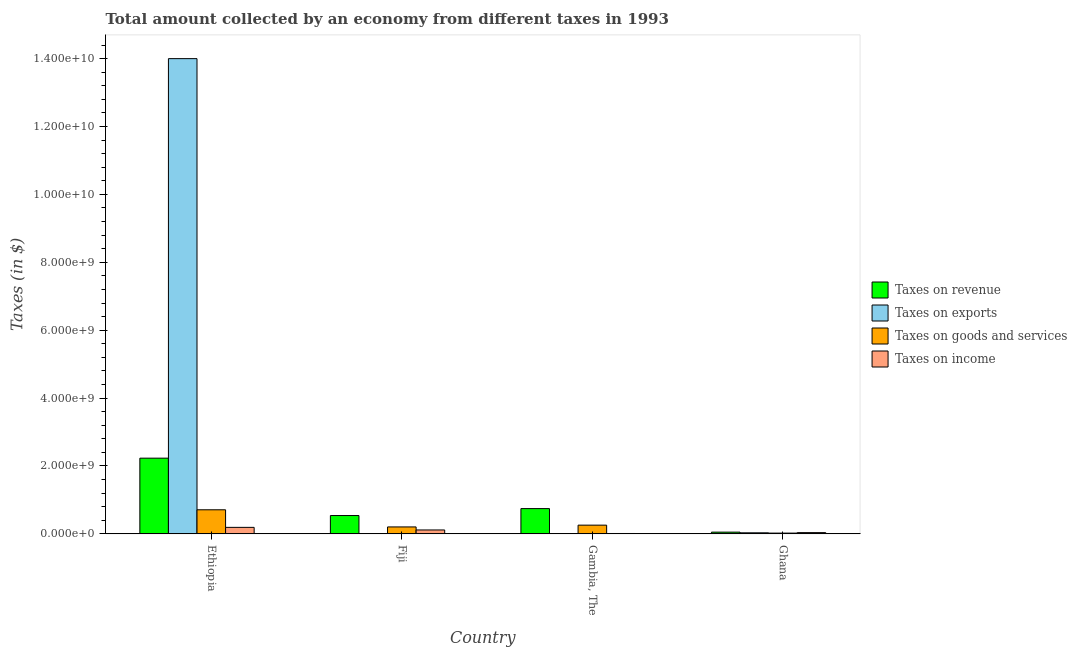What is the label of the 1st group of bars from the left?
Make the answer very short. Ethiopia. In how many cases, is the number of bars for a given country not equal to the number of legend labels?
Provide a short and direct response. 0. What is the amount collected as tax on goods in Ghana?
Give a very brief answer. 2.23e+07. Across all countries, what is the maximum amount collected as tax on income?
Give a very brief answer. 1.91e+08. Across all countries, what is the minimum amount collected as tax on exports?
Your response must be concise. 3.65e+05. In which country was the amount collected as tax on exports maximum?
Make the answer very short. Ethiopia. In which country was the amount collected as tax on revenue minimum?
Your answer should be compact. Ghana. What is the total amount collected as tax on income in the graph?
Offer a very short reply. 3.53e+08. What is the difference between the amount collected as tax on goods in Fiji and that in Ghana?
Your response must be concise. 1.82e+08. What is the difference between the amount collected as tax on income in Ghana and the amount collected as tax on revenue in Gambia, The?
Your response must be concise. -7.08e+08. What is the average amount collected as tax on goods per country?
Make the answer very short. 2.98e+08. What is the difference between the amount collected as tax on income and amount collected as tax on revenue in Ethiopia?
Ensure brevity in your answer.  -2.04e+09. What is the ratio of the amount collected as tax on goods in Gambia, The to that in Ghana?
Keep it short and to the point. 11.51. Is the amount collected as tax on revenue in Ethiopia less than that in Fiji?
Offer a terse response. No. What is the difference between the highest and the second highest amount collected as tax on exports?
Provide a short and direct response. 1.40e+1. What is the difference between the highest and the lowest amount collected as tax on income?
Give a very brief answer. 1.80e+08. Is it the case that in every country, the sum of the amount collected as tax on goods and amount collected as tax on revenue is greater than the sum of amount collected as tax on income and amount collected as tax on exports?
Offer a terse response. No. What does the 2nd bar from the left in Ghana represents?
Ensure brevity in your answer.  Taxes on exports. What does the 3rd bar from the right in Ethiopia represents?
Offer a terse response. Taxes on exports. Is it the case that in every country, the sum of the amount collected as tax on revenue and amount collected as tax on exports is greater than the amount collected as tax on goods?
Your answer should be very brief. Yes. How many bars are there?
Keep it short and to the point. 16. Are all the bars in the graph horizontal?
Give a very brief answer. No. How many countries are there in the graph?
Your response must be concise. 4. Does the graph contain any zero values?
Offer a very short reply. No. How are the legend labels stacked?
Make the answer very short. Vertical. What is the title of the graph?
Make the answer very short. Total amount collected by an economy from different taxes in 1993. What is the label or title of the X-axis?
Provide a short and direct response. Country. What is the label or title of the Y-axis?
Provide a short and direct response. Taxes (in $). What is the Taxes (in $) of Taxes on revenue in Ethiopia?
Your response must be concise. 2.23e+09. What is the Taxes (in $) of Taxes on exports in Ethiopia?
Your answer should be compact. 1.40e+1. What is the Taxes (in $) in Taxes on goods and services in Ethiopia?
Offer a very short reply. 7.09e+08. What is the Taxes (in $) of Taxes on income in Ethiopia?
Offer a very short reply. 1.91e+08. What is the Taxes (in $) in Taxes on revenue in Fiji?
Your response must be concise. 5.40e+08. What is the Taxes (in $) in Taxes on exports in Fiji?
Give a very brief answer. 1.00e+06. What is the Taxes (in $) of Taxes on goods and services in Fiji?
Your answer should be very brief. 2.04e+08. What is the Taxes (in $) of Taxes on income in Fiji?
Ensure brevity in your answer.  1.15e+08. What is the Taxes (in $) in Taxes on revenue in Gambia, The?
Your answer should be compact. 7.44e+08. What is the Taxes (in $) of Taxes on exports in Gambia, The?
Offer a very short reply. 3.65e+05. What is the Taxes (in $) in Taxes on goods and services in Gambia, The?
Offer a very short reply. 2.57e+08. What is the Taxes (in $) of Taxes on income in Gambia, The?
Provide a succinct answer. 1.10e+07. What is the Taxes (in $) in Taxes on revenue in Ghana?
Your answer should be compact. 5.09e+07. What is the Taxes (in $) in Taxes on exports in Ghana?
Ensure brevity in your answer.  3.10e+07. What is the Taxes (in $) in Taxes on goods and services in Ghana?
Provide a short and direct response. 2.23e+07. What is the Taxes (in $) of Taxes on income in Ghana?
Provide a short and direct response. 3.64e+07. Across all countries, what is the maximum Taxes (in $) in Taxes on revenue?
Provide a short and direct response. 2.23e+09. Across all countries, what is the maximum Taxes (in $) of Taxes on exports?
Give a very brief answer. 1.40e+1. Across all countries, what is the maximum Taxes (in $) of Taxes on goods and services?
Ensure brevity in your answer.  7.09e+08. Across all countries, what is the maximum Taxes (in $) in Taxes on income?
Your answer should be compact. 1.91e+08. Across all countries, what is the minimum Taxes (in $) in Taxes on revenue?
Provide a short and direct response. 5.09e+07. Across all countries, what is the minimum Taxes (in $) in Taxes on exports?
Make the answer very short. 3.65e+05. Across all countries, what is the minimum Taxes (in $) of Taxes on goods and services?
Provide a succinct answer. 2.23e+07. Across all countries, what is the minimum Taxes (in $) of Taxes on income?
Offer a terse response. 1.10e+07. What is the total Taxes (in $) in Taxes on revenue in the graph?
Your answer should be compact. 3.57e+09. What is the total Taxes (in $) of Taxes on exports in the graph?
Provide a succinct answer. 1.40e+1. What is the total Taxes (in $) of Taxes on goods and services in the graph?
Offer a terse response. 1.19e+09. What is the total Taxes (in $) of Taxes on income in the graph?
Give a very brief answer. 3.53e+08. What is the difference between the Taxes (in $) of Taxes on revenue in Ethiopia and that in Fiji?
Give a very brief answer. 1.69e+09. What is the difference between the Taxes (in $) in Taxes on exports in Ethiopia and that in Fiji?
Offer a terse response. 1.40e+1. What is the difference between the Taxes (in $) in Taxes on goods and services in Ethiopia and that in Fiji?
Your answer should be very brief. 5.05e+08. What is the difference between the Taxes (in $) of Taxes on income in Ethiopia and that in Fiji?
Keep it short and to the point. 7.64e+07. What is the difference between the Taxes (in $) of Taxes on revenue in Ethiopia and that in Gambia, The?
Your answer should be very brief. 1.49e+09. What is the difference between the Taxes (in $) of Taxes on exports in Ethiopia and that in Gambia, The?
Offer a terse response. 1.40e+1. What is the difference between the Taxes (in $) of Taxes on goods and services in Ethiopia and that in Gambia, The?
Your response must be concise. 4.53e+08. What is the difference between the Taxes (in $) of Taxes on income in Ethiopia and that in Gambia, The?
Give a very brief answer. 1.80e+08. What is the difference between the Taxes (in $) in Taxes on revenue in Ethiopia and that in Ghana?
Your answer should be compact. 2.18e+09. What is the difference between the Taxes (in $) of Taxes on exports in Ethiopia and that in Ghana?
Your answer should be compact. 1.40e+1. What is the difference between the Taxes (in $) in Taxes on goods and services in Ethiopia and that in Ghana?
Offer a terse response. 6.87e+08. What is the difference between the Taxes (in $) of Taxes on income in Ethiopia and that in Ghana?
Keep it short and to the point. 1.55e+08. What is the difference between the Taxes (in $) of Taxes on revenue in Fiji and that in Gambia, The?
Your answer should be very brief. -2.04e+08. What is the difference between the Taxes (in $) of Taxes on exports in Fiji and that in Gambia, The?
Your response must be concise. 6.35e+05. What is the difference between the Taxes (in $) of Taxes on goods and services in Fiji and that in Gambia, The?
Offer a very short reply. -5.24e+07. What is the difference between the Taxes (in $) in Taxes on income in Fiji and that in Gambia, The?
Keep it short and to the point. 1.04e+08. What is the difference between the Taxes (in $) of Taxes on revenue in Fiji and that in Ghana?
Make the answer very short. 4.89e+08. What is the difference between the Taxes (in $) in Taxes on exports in Fiji and that in Ghana?
Keep it short and to the point. -3.00e+07. What is the difference between the Taxes (in $) in Taxes on goods and services in Fiji and that in Ghana?
Offer a terse response. 1.82e+08. What is the difference between the Taxes (in $) of Taxes on income in Fiji and that in Ghana?
Your answer should be very brief. 7.83e+07. What is the difference between the Taxes (in $) in Taxes on revenue in Gambia, The and that in Ghana?
Make the answer very short. 6.93e+08. What is the difference between the Taxes (in $) in Taxes on exports in Gambia, The and that in Ghana?
Keep it short and to the point. -3.06e+07. What is the difference between the Taxes (in $) of Taxes on goods and services in Gambia, The and that in Ghana?
Provide a short and direct response. 2.34e+08. What is the difference between the Taxes (in $) of Taxes on income in Gambia, The and that in Ghana?
Provide a succinct answer. -2.54e+07. What is the difference between the Taxes (in $) of Taxes on revenue in Ethiopia and the Taxes (in $) of Taxes on exports in Fiji?
Offer a terse response. 2.23e+09. What is the difference between the Taxes (in $) in Taxes on revenue in Ethiopia and the Taxes (in $) in Taxes on goods and services in Fiji?
Your answer should be compact. 2.03e+09. What is the difference between the Taxes (in $) in Taxes on revenue in Ethiopia and the Taxes (in $) in Taxes on income in Fiji?
Offer a terse response. 2.12e+09. What is the difference between the Taxes (in $) of Taxes on exports in Ethiopia and the Taxes (in $) of Taxes on goods and services in Fiji?
Keep it short and to the point. 1.38e+1. What is the difference between the Taxes (in $) in Taxes on exports in Ethiopia and the Taxes (in $) in Taxes on income in Fiji?
Give a very brief answer. 1.39e+1. What is the difference between the Taxes (in $) of Taxes on goods and services in Ethiopia and the Taxes (in $) of Taxes on income in Fiji?
Provide a succinct answer. 5.94e+08. What is the difference between the Taxes (in $) of Taxes on revenue in Ethiopia and the Taxes (in $) of Taxes on exports in Gambia, The?
Your answer should be compact. 2.23e+09. What is the difference between the Taxes (in $) of Taxes on revenue in Ethiopia and the Taxes (in $) of Taxes on goods and services in Gambia, The?
Give a very brief answer. 1.97e+09. What is the difference between the Taxes (in $) of Taxes on revenue in Ethiopia and the Taxes (in $) of Taxes on income in Gambia, The?
Offer a very short reply. 2.22e+09. What is the difference between the Taxes (in $) of Taxes on exports in Ethiopia and the Taxes (in $) of Taxes on goods and services in Gambia, The?
Ensure brevity in your answer.  1.37e+1. What is the difference between the Taxes (in $) in Taxes on exports in Ethiopia and the Taxes (in $) in Taxes on income in Gambia, The?
Offer a very short reply. 1.40e+1. What is the difference between the Taxes (in $) of Taxes on goods and services in Ethiopia and the Taxes (in $) of Taxes on income in Gambia, The?
Your answer should be very brief. 6.98e+08. What is the difference between the Taxes (in $) of Taxes on revenue in Ethiopia and the Taxes (in $) of Taxes on exports in Ghana?
Provide a succinct answer. 2.20e+09. What is the difference between the Taxes (in $) in Taxes on revenue in Ethiopia and the Taxes (in $) in Taxes on goods and services in Ghana?
Offer a very short reply. 2.21e+09. What is the difference between the Taxes (in $) of Taxes on revenue in Ethiopia and the Taxes (in $) of Taxes on income in Ghana?
Make the answer very short. 2.19e+09. What is the difference between the Taxes (in $) of Taxes on exports in Ethiopia and the Taxes (in $) of Taxes on goods and services in Ghana?
Keep it short and to the point. 1.40e+1. What is the difference between the Taxes (in $) in Taxes on exports in Ethiopia and the Taxes (in $) in Taxes on income in Ghana?
Make the answer very short. 1.40e+1. What is the difference between the Taxes (in $) in Taxes on goods and services in Ethiopia and the Taxes (in $) in Taxes on income in Ghana?
Your answer should be very brief. 6.73e+08. What is the difference between the Taxes (in $) of Taxes on revenue in Fiji and the Taxes (in $) of Taxes on exports in Gambia, The?
Keep it short and to the point. 5.40e+08. What is the difference between the Taxes (in $) in Taxes on revenue in Fiji and the Taxes (in $) in Taxes on goods and services in Gambia, The?
Your answer should be compact. 2.83e+08. What is the difference between the Taxes (in $) in Taxes on revenue in Fiji and the Taxes (in $) in Taxes on income in Gambia, The?
Offer a very short reply. 5.29e+08. What is the difference between the Taxes (in $) of Taxes on exports in Fiji and the Taxes (in $) of Taxes on goods and services in Gambia, The?
Your response must be concise. -2.56e+08. What is the difference between the Taxes (in $) in Taxes on exports in Fiji and the Taxes (in $) in Taxes on income in Gambia, The?
Provide a short and direct response. -1.00e+07. What is the difference between the Taxes (in $) in Taxes on goods and services in Fiji and the Taxes (in $) in Taxes on income in Gambia, The?
Offer a terse response. 1.93e+08. What is the difference between the Taxes (in $) in Taxes on revenue in Fiji and the Taxes (in $) in Taxes on exports in Ghana?
Your answer should be compact. 5.09e+08. What is the difference between the Taxes (in $) of Taxes on revenue in Fiji and the Taxes (in $) of Taxes on goods and services in Ghana?
Offer a terse response. 5.18e+08. What is the difference between the Taxes (in $) of Taxes on revenue in Fiji and the Taxes (in $) of Taxes on income in Ghana?
Provide a short and direct response. 5.03e+08. What is the difference between the Taxes (in $) of Taxes on exports in Fiji and the Taxes (in $) of Taxes on goods and services in Ghana?
Provide a short and direct response. -2.13e+07. What is the difference between the Taxes (in $) in Taxes on exports in Fiji and the Taxes (in $) in Taxes on income in Ghana?
Make the answer very short. -3.54e+07. What is the difference between the Taxes (in $) in Taxes on goods and services in Fiji and the Taxes (in $) in Taxes on income in Ghana?
Offer a terse response. 1.68e+08. What is the difference between the Taxes (in $) of Taxes on revenue in Gambia, The and the Taxes (in $) of Taxes on exports in Ghana?
Your answer should be compact. 7.13e+08. What is the difference between the Taxes (in $) of Taxes on revenue in Gambia, The and the Taxes (in $) of Taxes on goods and services in Ghana?
Your answer should be very brief. 7.22e+08. What is the difference between the Taxes (in $) in Taxes on revenue in Gambia, The and the Taxes (in $) in Taxes on income in Ghana?
Your answer should be compact. 7.08e+08. What is the difference between the Taxes (in $) in Taxes on exports in Gambia, The and the Taxes (in $) in Taxes on goods and services in Ghana?
Provide a short and direct response. -2.19e+07. What is the difference between the Taxes (in $) in Taxes on exports in Gambia, The and the Taxes (in $) in Taxes on income in Ghana?
Offer a very short reply. -3.61e+07. What is the difference between the Taxes (in $) in Taxes on goods and services in Gambia, The and the Taxes (in $) in Taxes on income in Ghana?
Make the answer very short. 2.20e+08. What is the average Taxes (in $) in Taxes on revenue per country?
Provide a short and direct response. 8.91e+08. What is the average Taxes (in $) in Taxes on exports per country?
Provide a succinct answer. 3.51e+09. What is the average Taxes (in $) in Taxes on goods and services per country?
Ensure brevity in your answer.  2.98e+08. What is the average Taxes (in $) in Taxes on income per country?
Keep it short and to the point. 8.83e+07. What is the difference between the Taxes (in $) of Taxes on revenue and Taxes (in $) of Taxes on exports in Ethiopia?
Your answer should be very brief. -1.18e+1. What is the difference between the Taxes (in $) of Taxes on revenue and Taxes (in $) of Taxes on goods and services in Ethiopia?
Give a very brief answer. 1.52e+09. What is the difference between the Taxes (in $) in Taxes on revenue and Taxes (in $) in Taxes on income in Ethiopia?
Offer a very short reply. 2.04e+09. What is the difference between the Taxes (in $) of Taxes on exports and Taxes (in $) of Taxes on goods and services in Ethiopia?
Provide a short and direct response. 1.33e+1. What is the difference between the Taxes (in $) in Taxes on exports and Taxes (in $) in Taxes on income in Ethiopia?
Give a very brief answer. 1.38e+1. What is the difference between the Taxes (in $) of Taxes on goods and services and Taxes (in $) of Taxes on income in Ethiopia?
Keep it short and to the point. 5.18e+08. What is the difference between the Taxes (in $) of Taxes on revenue and Taxes (in $) of Taxes on exports in Fiji?
Offer a terse response. 5.39e+08. What is the difference between the Taxes (in $) of Taxes on revenue and Taxes (in $) of Taxes on goods and services in Fiji?
Keep it short and to the point. 3.36e+08. What is the difference between the Taxes (in $) in Taxes on revenue and Taxes (in $) in Taxes on income in Fiji?
Ensure brevity in your answer.  4.25e+08. What is the difference between the Taxes (in $) in Taxes on exports and Taxes (in $) in Taxes on goods and services in Fiji?
Keep it short and to the point. -2.03e+08. What is the difference between the Taxes (in $) in Taxes on exports and Taxes (in $) in Taxes on income in Fiji?
Provide a succinct answer. -1.14e+08. What is the difference between the Taxes (in $) of Taxes on goods and services and Taxes (in $) of Taxes on income in Fiji?
Your response must be concise. 8.94e+07. What is the difference between the Taxes (in $) of Taxes on revenue and Taxes (in $) of Taxes on exports in Gambia, The?
Offer a very short reply. 7.44e+08. What is the difference between the Taxes (in $) of Taxes on revenue and Taxes (in $) of Taxes on goods and services in Gambia, The?
Ensure brevity in your answer.  4.88e+08. What is the difference between the Taxes (in $) in Taxes on revenue and Taxes (in $) in Taxes on income in Gambia, The?
Provide a short and direct response. 7.33e+08. What is the difference between the Taxes (in $) in Taxes on exports and Taxes (in $) in Taxes on goods and services in Gambia, The?
Give a very brief answer. -2.56e+08. What is the difference between the Taxes (in $) in Taxes on exports and Taxes (in $) in Taxes on income in Gambia, The?
Your answer should be compact. -1.07e+07. What is the difference between the Taxes (in $) in Taxes on goods and services and Taxes (in $) in Taxes on income in Gambia, The?
Offer a terse response. 2.46e+08. What is the difference between the Taxes (in $) in Taxes on revenue and Taxes (in $) in Taxes on exports in Ghana?
Offer a very short reply. 1.99e+07. What is the difference between the Taxes (in $) in Taxes on revenue and Taxes (in $) in Taxes on goods and services in Ghana?
Keep it short and to the point. 2.86e+07. What is the difference between the Taxes (in $) in Taxes on revenue and Taxes (in $) in Taxes on income in Ghana?
Your answer should be compact. 1.45e+07. What is the difference between the Taxes (in $) in Taxes on exports and Taxes (in $) in Taxes on goods and services in Ghana?
Your answer should be compact. 8.71e+06. What is the difference between the Taxes (in $) in Taxes on exports and Taxes (in $) in Taxes on income in Ghana?
Provide a short and direct response. -5.44e+06. What is the difference between the Taxes (in $) in Taxes on goods and services and Taxes (in $) in Taxes on income in Ghana?
Your response must be concise. -1.42e+07. What is the ratio of the Taxes (in $) in Taxes on revenue in Ethiopia to that in Fiji?
Offer a very short reply. 4.13. What is the ratio of the Taxes (in $) of Taxes on exports in Ethiopia to that in Fiji?
Your answer should be very brief. 1.40e+04. What is the ratio of the Taxes (in $) in Taxes on goods and services in Ethiopia to that in Fiji?
Your response must be concise. 3.47. What is the ratio of the Taxes (in $) in Taxes on income in Ethiopia to that in Fiji?
Keep it short and to the point. 1.67. What is the ratio of the Taxes (in $) of Taxes on revenue in Ethiopia to that in Gambia, The?
Make the answer very short. 3. What is the ratio of the Taxes (in $) of Taxes on exports in Ethiopia to that in Gambia, The?
Your response must be concise. 3.84e+04. What is the ratio of the Taxes (in $) of Taxes on goods and services in Ethiopia to that in Gambia, The?
Keep it short and to the point. 2.76. What is the ratio of the Taxes (in $) of Taxes on income in Ethiopia to that in Gambia, The?
Give a very brief answer. 17.33. What is the ratio of the Taxes (in $) of Taxes on revenue in Ethiopia to that in Ghana?
Your answer should be very brief. 43.8. What is the ratio of the Taxes (in $) in Taxes on exports in Ethiopia to that in Ghana?
Your answer should be compact. 451.61. What is the ratio of the Taxes (in $) in Taxes on goods and services in Ethiopia to that in Ghana?
Your answer should be very brief. 31.82. What is the ratio of the Taxes (in $) in Taxes on income in Ethiopia to that in Ghana?
Offer a terse response. 5.24. What is the ratio of the Taxes (in $) of Taxes on revenue in Fiji to that in Gambia, The?
Provide a short and direct response. 0.73. What is the ratio of the Taxes (in $) in Taxes on exports in Fiji to that in Gambia, The?
Provide a short and direct response. 2.74. What is the ratio of the Taxes (in $) of Taxes on goods and services in Fiji to that in Gambia, The?
Make the answer very short. 0.8. What is the ratio of the Taxes (in $) in Taxes on income in Fiji to that in Gambia, The?
Your answer should be compact. 10.4. What is the ratio of the Taxes (in $) of Taxes on revenue in Fiji to that in Ghana?
Provide a succinct answer. 10.6. What is the ratio of the Taxes (in $) of Taxes on exports in Fiji to that in Ghana?
Your response must be concise. 0.03. What is the ratio of the Taxes (in $) in Taxes on goods and services in Fiji to that in Ghana?
Offer a terse response. 9.16. What is the ratio of the Taxes (in $) of Taxes on income in Fiji to that in Ghana?
Provide a short and direct response. 3.15. What is the ratio of the Taxes (in $) of Taxes on revenue in Gambia, The to that in Ghana?
Provide a succinct answer. 14.62. What is the ratio of the Taxes (in $) in Taxes on exports in Gambia, The to that in Ghana?
Your answer should be compact. 0.01. What is the ratio of the Taxes (in $) of Taxes on goods and services in Gambia, The to that in Ghana?
Offer a very short reply. 11.51. What is the ratio of the Taxes (in $) in Taxes on income in Gambia, The to that in Ghana?
Offer a terse response. 0.3. What is the difference between the highest and the second highest Taxes (in $) in Taxes on revenue?
Your answer should be very brief. 1.49e+09. What is the difference between the highest and the second highest Taxes (in $) of Taxes on exports?
Make the answer very short. 1.40e+1. What is the difference between the highest and the second highest Taxes (in $) of Taxes on goods and services?
Give a very brief answer. 4.53e+08. What is the difference between the highest and the second highest Taxes (in $) of Taxes on income?
Keep it short and to the point. 7.64e+07. What is the difference between the highest and the lowest Taxes (in $) of Taxes on revenue?
Offer a terse response. 2.18e+09. What is the difference between the highest and the lowest Taxes (in $) of Taxes on exports?
Provide a short and direct response. 1.40e+1. What is the difference between the highest and the lowest Taxes (in $) in Taxes on goods and services?
Offer a terse response. 6.87e+08. What is the difference between the highest and the lowest Taxes (in $) in Taxes on income?
Offer a very short reply. 1.80e+08. 